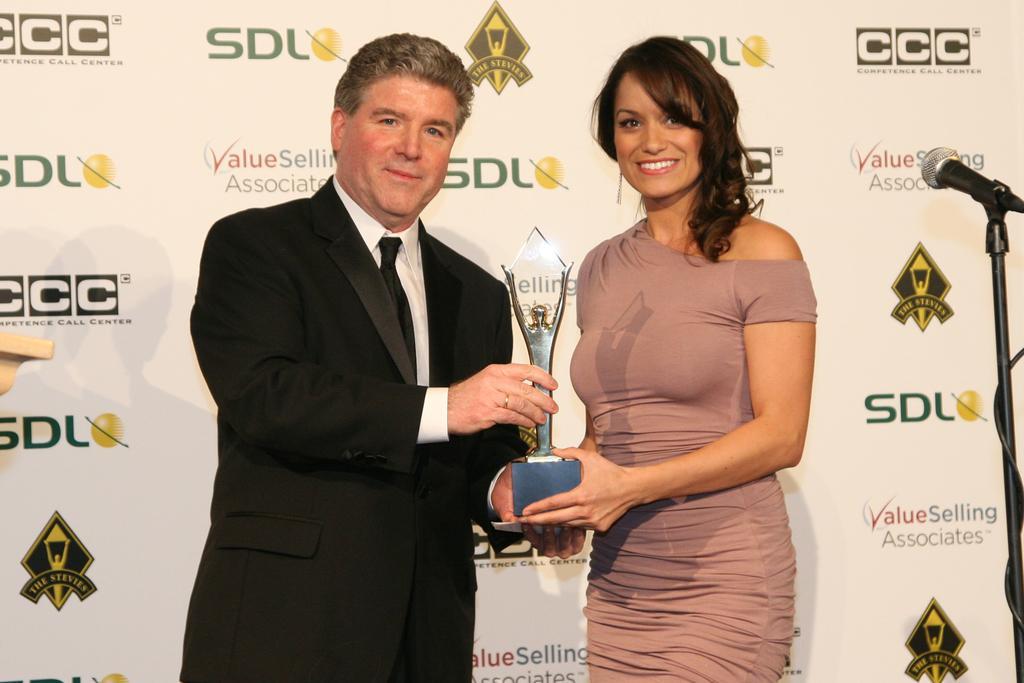Can you describe this image briefly? In this picture there is a woman standing and smiling and holding the object and there is a man standing and holding the object. At the back there is a board and there is text on the board. On the right side of the image there is a microphone. 